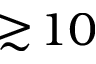Convert formula to latex. <formula><loc_0><loc_0><loc_500><loc_500>\gtrsim \, 1 0</formula> 